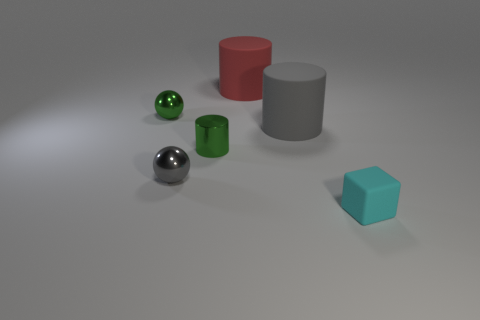Add 3 large yellow things. How many objects exist? 9 Subtract all balls. How many objects are left? 4 Add 6 gray shiny objects. How many gray shiny objects are left? 7 Add 2 small green metallic balls. How many small green metallic balls exist? 3 Subtract 1 gray spheres. How many objects are left? 5 Subtract all matte cylinders. Subtract all cyan cubes. How many objects are left? 3 